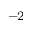<formula> <loc_0><loc_0><loc_500><loc_500>^ { - 2 }</formula> 